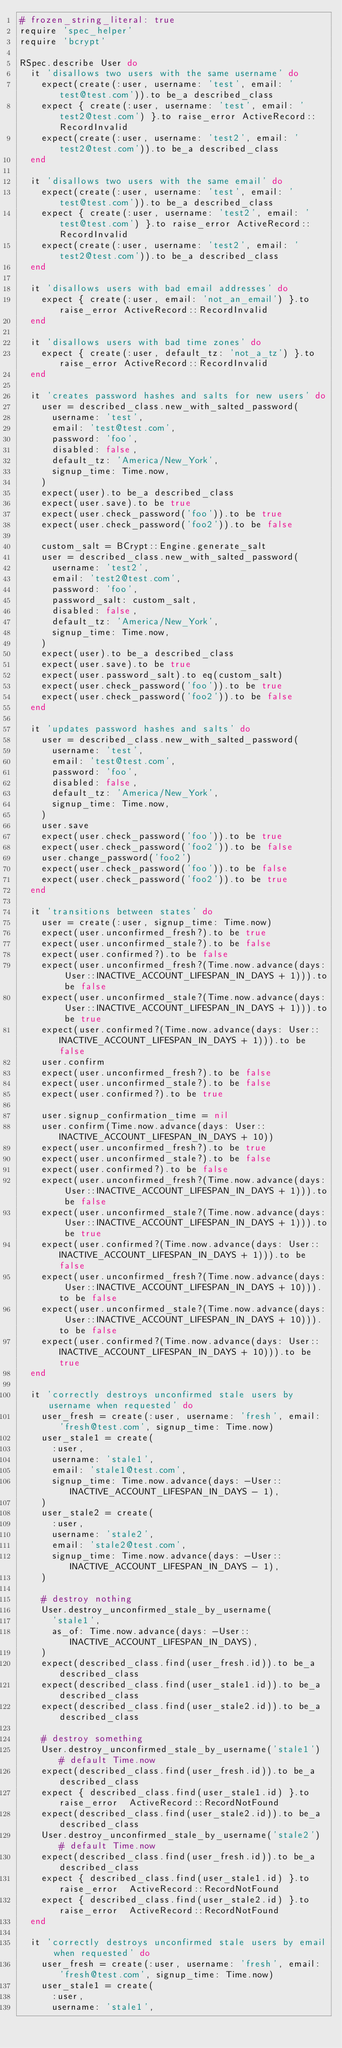<code> <loc_0><loc_0><loc_500><loc_500><_Ruby_># frozen_string_literal: true
require 'spec_helper'
require 'bcrypt'

RSpec.describe User do
  it 'disallows two users with the same username' do
    expect(create(:user, username: 'test', email: 'test@test.com')).to be_a described_class
    expect { create(:user, username: 'test', email: 'test2@test.com') }.to raise_error ActiveRecord::RecordInvalid
    expect(create(:user, username: 'test2', email: 'test2@test.com')).to be_a described_class
  end

  it 'disallows two users with the same email' do
    expect(create(:user, username: 'test', email: 'test@test.com')).to be_a described_class
    expect { create(:user, username: 'test2', email: 'test@test.com') }.to raise_error ActiveRecord::RecordInvalid
    expect(create(:user, username: 'test2', email: 'test2@test.com')).to be_a described_class
  end

  it 'disallows users with bad email addresses' do
    expect { create(:user, email: 'not_an_email') }.to raise_error ActiveRecord::RecordInvalid
  end

  it 'disallows users with bad time zones' do
    expect { create(:user, default_tz: 'not_a_tz') }.to raise_error ActiveRecord::RecordInvalid
  end

  it 'creates password hashes and salts for new users' do
    user = described_class.new_with_salted_password(
      username: 'test',
      email: 'test@test.com',
      password: 'foo',
      disabled: false,
      default_tz: 'America/New_York',
      signup_time: Time.now,
    )
    expect(user).to be_a described_class
    expect(user.save).to be true
    expect(user.check_password('foo')).to be true
    expect(user.check_password('foo2')).to be false

    custom_salt = BCrypt::Engine.generate_salt
    user = described_class.new_with_salted_password(
      username: 'test2',
      email: 'test2@test.com',
      password: 'foo',
      password_salt: custom_salt,
      disabled: false,
      default_tz: 'America/New_York',
      signup_time: Time.now,
    )
    expect(user).to be_a described_class
    expect(user.save).to be true
    expect(user.password_salt).to eq(custom_salt)
    expect(user.check_password('foo')).to be true
    expect(user.check_password('foo2')).to be false
  end

  it 'updates password hashes and salts' do
    user = described_class.new_with_salted_password(
      username: 'test',
      email: 'test@test.com',
      password: 'foo',
      disabled: false,
      default_tz: 'America/New_York',
      signup_time: Time.now,
    )
    user.save
    expect(user.check_password('foo')).to be true
    expect(user.check_password('foo2')).to be false
    user.change_password('foo2')
    expect(user.check_password('foo')).to be false
    expect(user.check_password('foo2')).to be true
  end

  it 'transitions between states' do
    user = create(:user, signup_time: Time.now)
    expect(user.unconfirmed_fresh?).to be true
    expect(user.unconfirmed_stale?).to be false
    expect(user.confirmed?).to be false
    expect(user.unconfirmed_fresh?(Time.now.advance(days: User::INACTIVE_ACCOUNT_LIFESPAN_IN_DAYS + 1))).to be false
    expect(user.unconfirmed_stale?(Time.now.advance(days: User::INACTIVE_ACCOUNT_LIFESPAN_IN_DAYS + 1))).to be true
    expect(user.confirmed?(Time.now.advance(days: User::INACTIVE_ACCOUNT_LIFESPAN_IN_DAYS + 1))).to be false
    user.confirm
    expect(user.unconfirmed_fresh?).to be false
    expect(user.unconfirmed_stale?).to be false
    expect(user.confirmed?).to be true

    user.signup_confirmation_time = nil
    user.confirm(Time.now.advance(days: User::INACTIVE_ACCOUNT_LIFESPAN_IN_DAYS + 10))
    expect(user.unconfirmed_fresh?).to be true
    expect(user.unconfirmed_stale?).to be false
    expect(user.confirmed?).to be false
    expect(user.unconfirmed_fresh?(Time.now.advance(days: User::INACTIVE_ACCOUNT_LIFESPAN_IN_DAYS + 1))).to be false
    expect(user.unconfirmed_stale?(Time.now.advance(days: User::INACTIVE_ACCOUNT_LIFESPAN_IN_DAYS + 1))).to be true
    expect(user.confirmed?(Time.now.advance(days: User::INACTIVE_ACCOUNT_LIFESPAN_IN_DAYS + 1))).to be false
    expect(user.unconfirmed_fresh?(Time.now.advance(days: User::INACTIVE_ACCOUNT_LIFESPAN_IN_DAYS + 10))).to be false
    expect(user.unconfirmed_stale?(Time.now.advance(days: User::INACTIVE_ACCOUNT_LIFESPAN_IN_DAYS + 10))).to be false
    expect(user.confirmed?(Time.now.advance(days: User::INACTIVE_ACCOUNT_LIFESPAN_IN_DAYS + 10))).to be true
  end

  it 'correctly destroys unconfirmed stale users by username when requested' do
    user_fresh = create(:user, username: 'fresh', email: 'fresh@test.com', signup_time: Time.now)
    user_stale1 = create(
      :user,
      username: 'stale1',
      email: 'stale1@test.com',
      signup_time: Time.now.advance(days: -User::INACTIVE_ACCOUNT_LIFESPAN_IN_DAYS - 1),
    )
    user_stale2 = create(
      :user,
      username: 'stale2',
      email: 'stale2@test.com',
      signup_time: Time.now.advance(days: -User::INACTIVE_ACCOUNT_LIFESPAN_IN_DAYS - 1),
    )

    # destroy nothing
    User.destroy_unconfirmed_stale_by_username(
      'stale1',
      as_of: Time.now.advance(days: -User::INACTIVE_ACCOUNT_LIFESPAN_IN_DAYS),
    )
    expect(described_class.find(user_fresh.id)).to be_a described_class
    expect(described_class.find(user_stale1.id)).to be_a described_class
    expect(described_class.find(user_stale2.id)).to be_a described_class

    # destroy something
    User.destroy_unconfirmed_stale_by_username('stale1') # default Time.now
    expect(described_class.find(user_fresh.id)).to be_a described_class
    expect { described_class.find(user_stale1.id) }.to raise_error  ActiveRecord::RecordNotFound
    expect(described_class.find(user_stale2.id)).to be_a described_class
    User.destroy_unconfirmed_stale_by_username('stale2') # default Time.now
    expect(described_class.find(user_fresh.id)).to be_a described_class
    expect { described_class.find(user_stale1.id) }.to raise_error  ActiveRecord::RecordNotFound
    expect { described_class.find(user_stale2.id) }.to raise_error  ActiveRecord::RecordNotFound
  end

  it 'correctly destroys unconfirmed stale users by email when requested' do
    user_fresh = create(:user, username: 'fresh', email: 'fresh@test.com', signup_time: Time.now)
    user_stale1 = create(
      :user,
      username: 'stale1',</code> 